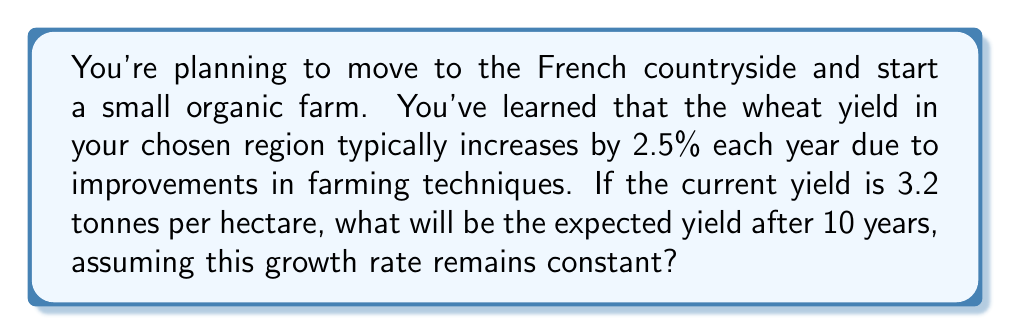Show me your answer to this math problem. Let's approach this step-by-step using an exponential growth model:

1) The general form of an exponential growth function is:
   $A(t) = A_0(1 + r)^t$
   where $A(t)$ is the amount after time $t$, $A_0$ is the initial amount, $r$ is the growth rate, and $t$ is the time period.

2) In this problem:
   $A_0 = 3.2$ tonnes per hectare (initial yield)
   $r = 0.025$ (2.5% growth rate)
   $t = 10$ years

3) Plugging these values into our exponential growth formula:
   $A(10) = 3.2(1 + 0.025)^{10}$

4) Simplify inside the parentheses:
   $A(10) = 3.2(1.025)^{10}$

5) Calculate $(1.025)^{10}$:
   $(1.025)^{10} \approx 1.2801$

6) Multiply by 3.2:
   $A(10) = 3.2 * 1.2801 \approx 4.0963$

Therefore, after 10 years, the expected yield will be approximately 4.0963 tonnes per hectare.
Answer: 4.10 tonnes per hectare 